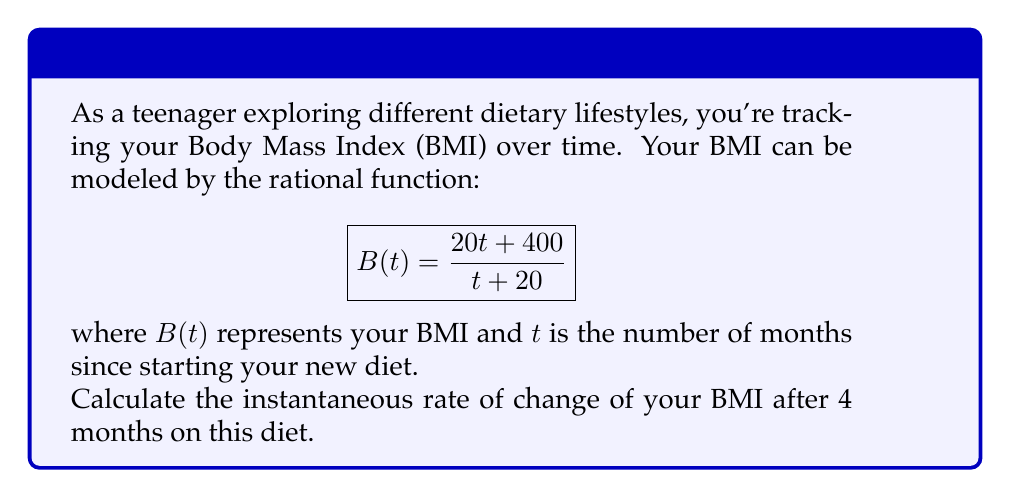Provide a solution to this math problem. To find the instantaneous rate of change, we need to calculate the derivative of the BMI function $B(t)$ and then evaluate it at $t = 4$.

Step 1: Calculate the derivative of $B(t)$ using the quotient rule.
Let $u = 20t + 400$ and $v = t + 20$
$$B'(t) = \frac{u'v - uv'}{v^2} = \frac{20(t+20) - (20t+400)(1)}{(t+20)^2}$$

Step 2: Simplify the numerator
$$B'(t) = \frac{20t + 400 - 20t - 400}{(t+20)^2} = \frac{0}{(t+20)^2}$$

Step 3: Simplify the final expression
$$B'(t) = 0$$

Step 4: Evaluate $B'(t)$ at $t = 4$
$$B'(4) = 0$$

The instantaneous rate of change is 0, meaning the BMI is not changing at this point in time.
Answer: 0 